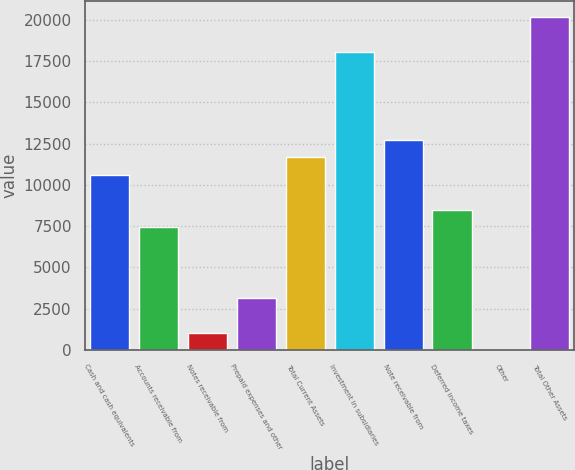Convert chart. <chart><loc_0><loc_0><loc_500><loc_500><bar_chart><fcel>Cash and cash equivalents<fcel>Accounts receivable from<fcel>Notes receivable from<fcel>Prepaid expenses and other<fcel>Total Current Assets<fcel>Investment in subsidiaries<fcel>Note receivable from<fcel>Deferred income taxes<fcel>Other<fcel>Total Other Assets<nl><fcel>10604.4<fcel>7423.41<fcel>1061.43<fcel>3182.09<fcel>11664.7<fcel>18026.7<fcel>12725.1<fcel>8483.74<fcel>1.1<fcel>20147.4<nl></chart> 